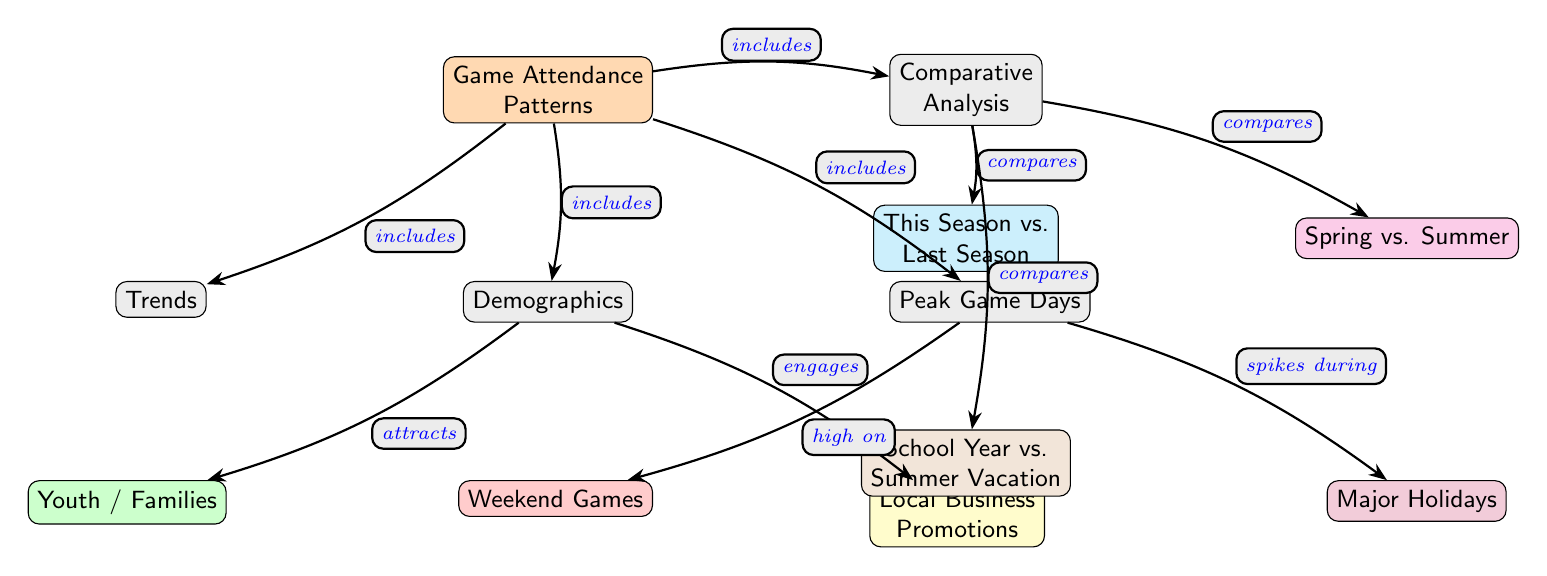What are the main categories in the diagram? The diagram has four main categories connected to the central node "Game Attendance Patterns": Trends, Demographics, Peak Game Days, and Comparative Analysis.
Answer: Trends, Demographics, Peak Game Days, Comparative Analysis How many sub-nodes are associated with Demographics? There are two sub-nodes associated with Demographics: Youth / Families and Local Business Promotions.
Answer: 2 What type of days are highlighted under Peak Game Days? Two types of days are highlighted: Weekend Games and Major Holidays. These represent specific periods when attendance is expected to be high.
Answer: Weekend Games, Major Holidays Which category includes "This Season vs. Last Season"? "This Season vs. Last Season" is included in the Comparative Analysis category, which encompasses comparisons of game attendance data among different timelines.
Answer: Comparative Analysis Which sub-node is linked to Local Business Promotions? The diagram indicates that Local Business Promotions engages with the Demographics node. This means it draws in attendance-related demographics, particularly through partnership promotions.
Answer: Local Business Promotions How does attendance relate to Weekend Games in the Peak Game Days category? Attendance is described as high on Weekend Games, indicating a strong relationship where weekends typically draw larger crowds, resulting in peaks in attendance.
Answer: High What are the relationships represented in the edges between the main nodes? The relationships represented include "includes," "attracts," "engages," "high on," and "compares." These indicate how the categories interconnect and contribute to understanding game attendance patterns.
Answer: Includes, attracts, engages, high on, compares Which demographic group is attracted to game attendance? The Youth / Families demographic group is specifically highlighted as being attracted to game attendance, emphasizing their importance in attendance patterns.
Answer: Youth / Families What does the edge labeled "spikes during" connect to? The edge labeled "spikes during" connects the Peak Game Days category to the Major Holidays sub-node, indicating that attendance significantly increases during these holidays.
Answer: Major Holidays 